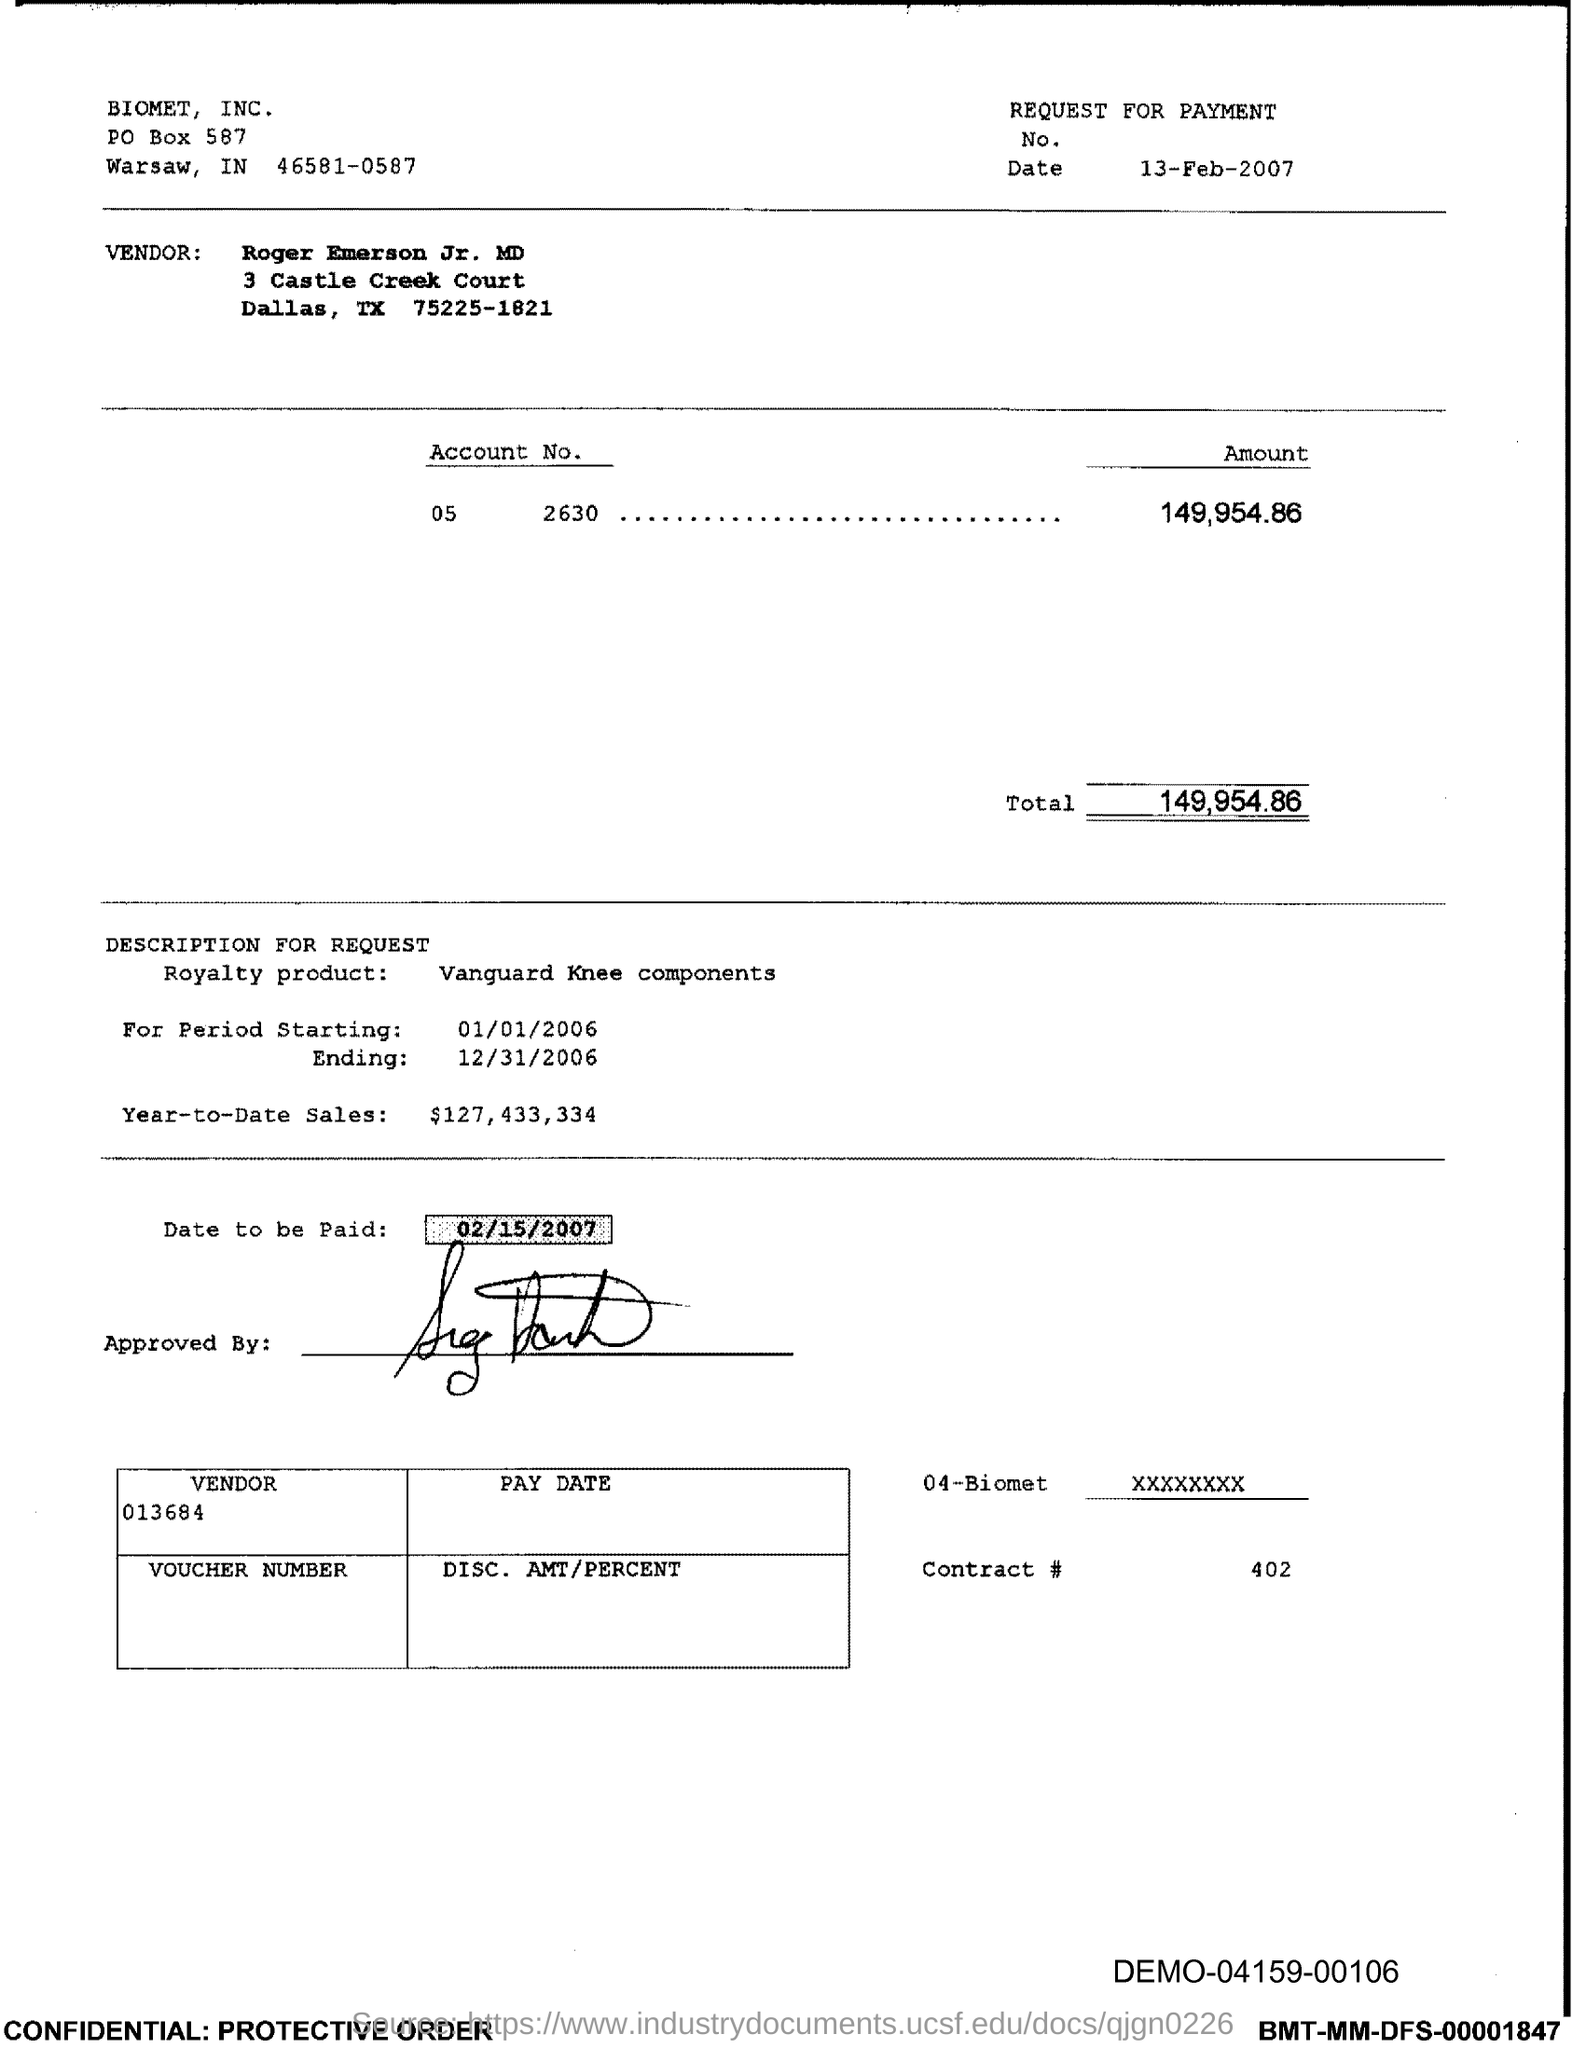What is the Contract # Number?
Your response must be concise. 402. What is the Total?
Your answer should be compact. 149,954.86. 